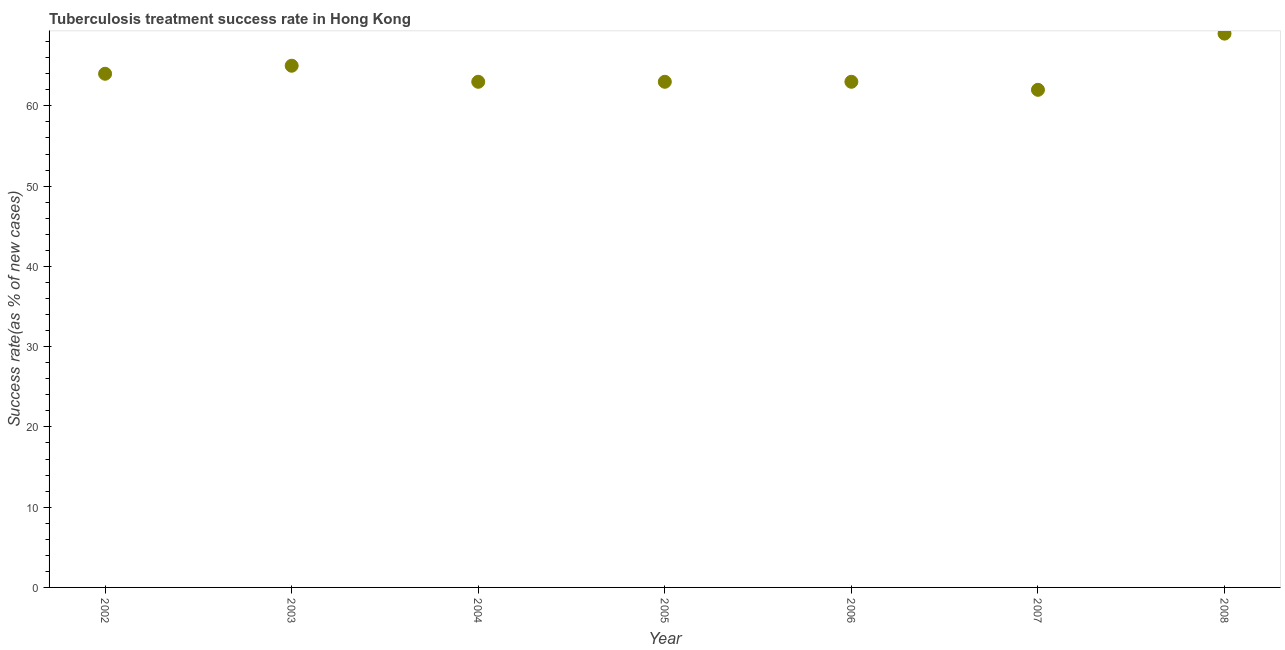What is the tuberculosis treatment success rate in 2007?
Your answer should be compact. 62. Across all years, what is the maximum tuberculosis treatment success rate?
Your response must be concise. 69. Across all years, what is the minimum tuberculosis treatment success rate?
Make the answer very short. 62. In which year was the tuberculosis treatment success rate minimum?
Your answer should be very brief. 2007. What is the sum of the tuberculosis treatment success rate?
Ensure brevity in your answer.  449. What is the average tuberculosis treatment success rate per year?
Offer a very short reply. 64.14. In how many years, is the tuberculosis treatment success rate greater than 56 %?
Provide a succinct answer. 7. What is the ratio of the tuberculosis treatment success rate in 2005 to that in 2006?
Your answer should be compact. 1. Is the difference between the tuberculosis treatment success rate in 2002 and 2006 greater than the difference between any two years?
Provide a short and direct response. No. What is the difference between the highest and the second highest tuberculosis treatment success rate?
Keep it short and to the point. 4. What is the difference between the highest and the lowest tuberculosis treatment success rate?
Provide a short and direct response. 7. How many years are there in the graph?
Give a very brief answer. 7. Are the values on the major ticks of Y-axis written in scientific E-notation?
Give a very brief answer. No. Does the graph contain any zero values?
Your answer should be compact. No. Does the graph contain grids?
Your answer should be compact. No. What is the title of the graph?
Make the answer very short. Tuberculosis treatment success rate in Hong Kong. What is the label or title of the X-axis?
Your answer should be compact. Year. What is the label or title of the Y-axis?
Keep it short and to the point. Success rate(as % of new cases). What is the Success rate(as % of new cases) in 2004?
Your response must be concise. 63. What is the Success rate(as % of new cases) in 2005?
Offer a very short reply. 63. What is the Success rate(as % of new cases) in 2006?
Make the answer very short. 63. What is the Success rate(as % of new cases) in 2007?
Give a very brief answer. 62. What is the difference between the Success rate(as % of new cases) in 2002 and 2006?
Offer a terse response. 1. What is the difference between the Success rate(as % of new cases) in 2002 and 2007?
Provide a short and direct response. 2. What is the difference between the Success rate(as % of new cases) in 2003 and 2007?
Your answer should be compact. 3. What is the difference between the Success rate(as % of new cases) in 2003 and 2008?
Your answer should be very brief. -4. What is the difference between the Success rate(as % of new cases) in 2004 and 2005?
Provide a short and direct response. 0. What is the difference between the Success rate(as % of new cases) in 2004 and 2006?
Offer a terse response. 0. What is the difference between the Success rate(as % of new cases) in 2005 and 2006?
Ensure brevity in your answer.  0. What is the difference between the Success rate(as % of new cases) in 2005 and 2007?
Ensure brevity in your answer.  1. What is the difference between the Success rate(as % of new cases) in 2005 and 2008?
Provide a succinct answer. -6. What is the difference between the Success rate(as % of new cases) in 2006 and 2008?
Your response must be concise. -6. What is the ratio of the Success rate(as % of new cases) in 2002 to that in 2003?
Provide a succinct answer. 0.98. What is the ratio of the Success rate(as % of new cases) in 2002 to that in 2004?
Ensure brevity in your answer.  1.02. What is the ratio of the Success rate(as % of new cases) in 2002 to that in 2007?
Offer a very short reply. 1.03. What is the ratio of the Success rate(as % of new cases) in 2002 to that in 2008?
Give a very brief answer. 0.93. What is the ratio of the Success rate(as % of new cases) in 2003 to that in 2004?
Your response must be concise. 1.03. What is the ratio of the Success rate(as % of new cases) in 2003 to that in 2005?
Your response must be concise. 1.03. What is the ratio of the Success rate(as % of new cases) in 2003 to that in 2006?
Offer a terse response. 1.03. What is the ratio of the Success rate(as % of new cases) in 2003 to that in 2007?
Provide a succinct answer. 1.05. What is the ratio of the Success rate(as % of new cases) in 2003 to that in 2008?
Provide a succinct answer. 0.94. What is the ratio of the Success rate(as % of new cases) in 2004 to that in 2006?
Provide a short and direct response. 1. What is the ratio of the Success rate(as % of new cases) in 2004 to that in 2007?
Offer a very short reply. 1.02. What is the ratio of the Success rate(as % of new cases) in 2005 to that in 2006?
Provide a short and direct response. 1. What is the ratio of the Success rate(as % of new cases) in 2005 to that in 2008?
Make the answer very short. 0.91. What is the ratio of the Success rate(as % of new cases) in 2006 to that in 2007?
Ensure brevity in your answer.  1.02. What is the ratio of the Success rate(as % of new cases) in 2007 to that in 2008?
Ensure brevity in your answer.  0.9. 